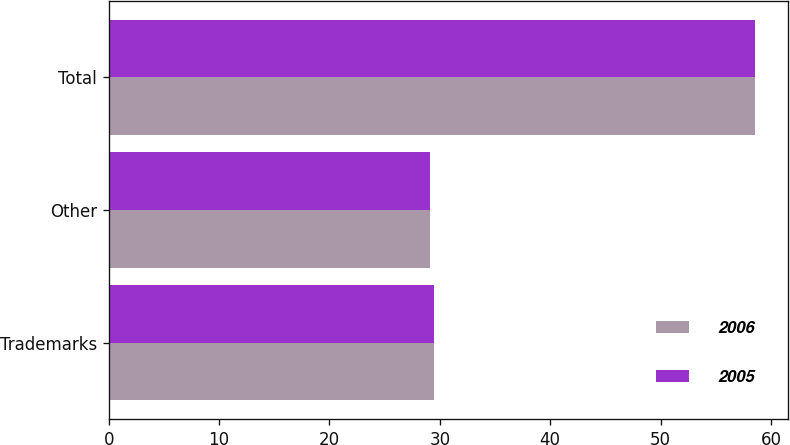<chart> <loc_0><loc_0><loc_500><loc_500><stacked_bar_chart><ecel><fcel>Trademarks<fcel>Other<fcel>Total<nl><fcel>2006<fcel>29.5<fcel>29.1<fcel>58.6<nl><fcel>2005<fcel>29.5<fcel>29.1<fcel>58.6<nl></chart> 